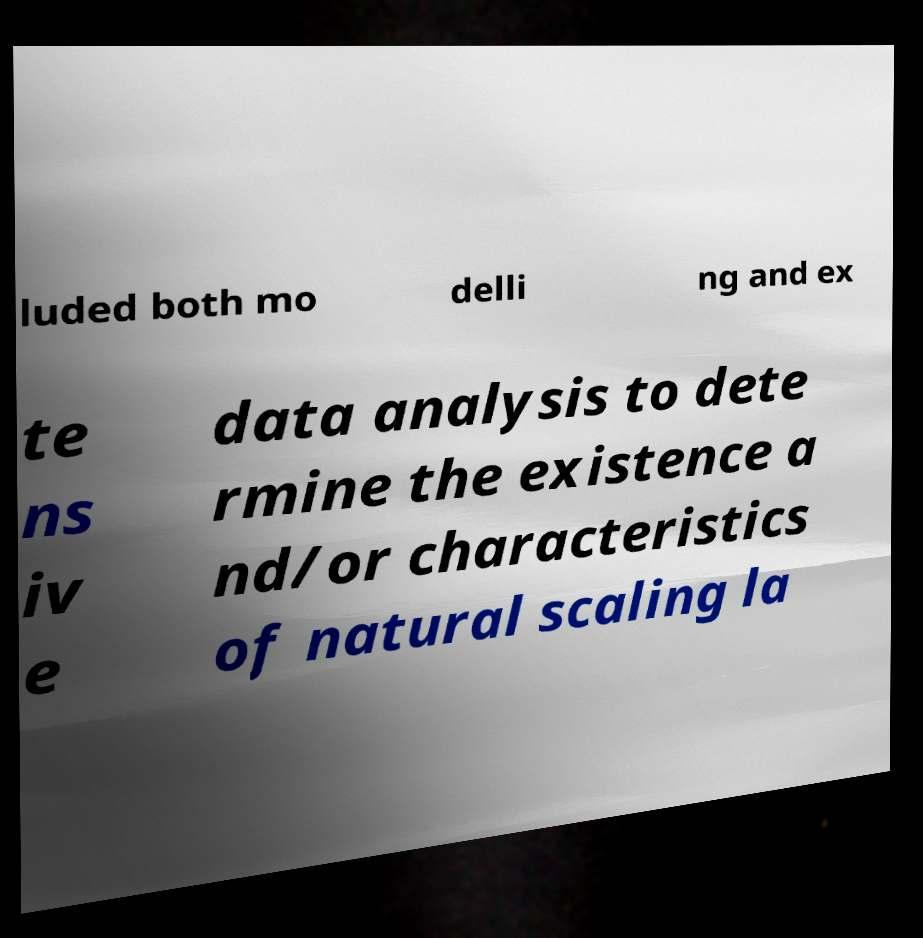Please read and relay the text visible in this image. What does it say? luded both mo delli ng and ex te ns iv e data analysis to dete rmine the existence a nd/or characteristics of natural scaling la 